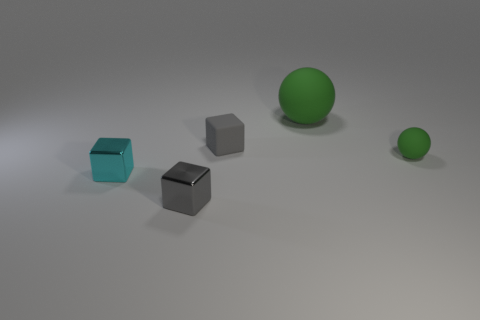Add 4 large green balls. How many objects exist? 9 Subtract all spheres. How many objects are left? 3 Add 5 matte cubes. How many matte cubes are left? 6 Add 2 small blue cylinders. How many small blue cylinders exist? 2 Subtract 0 purple spheres. How many objects are left? 5 Subtract all cyan metallic cubes. Subtract all tiny gray things. How many objects are left? 2 